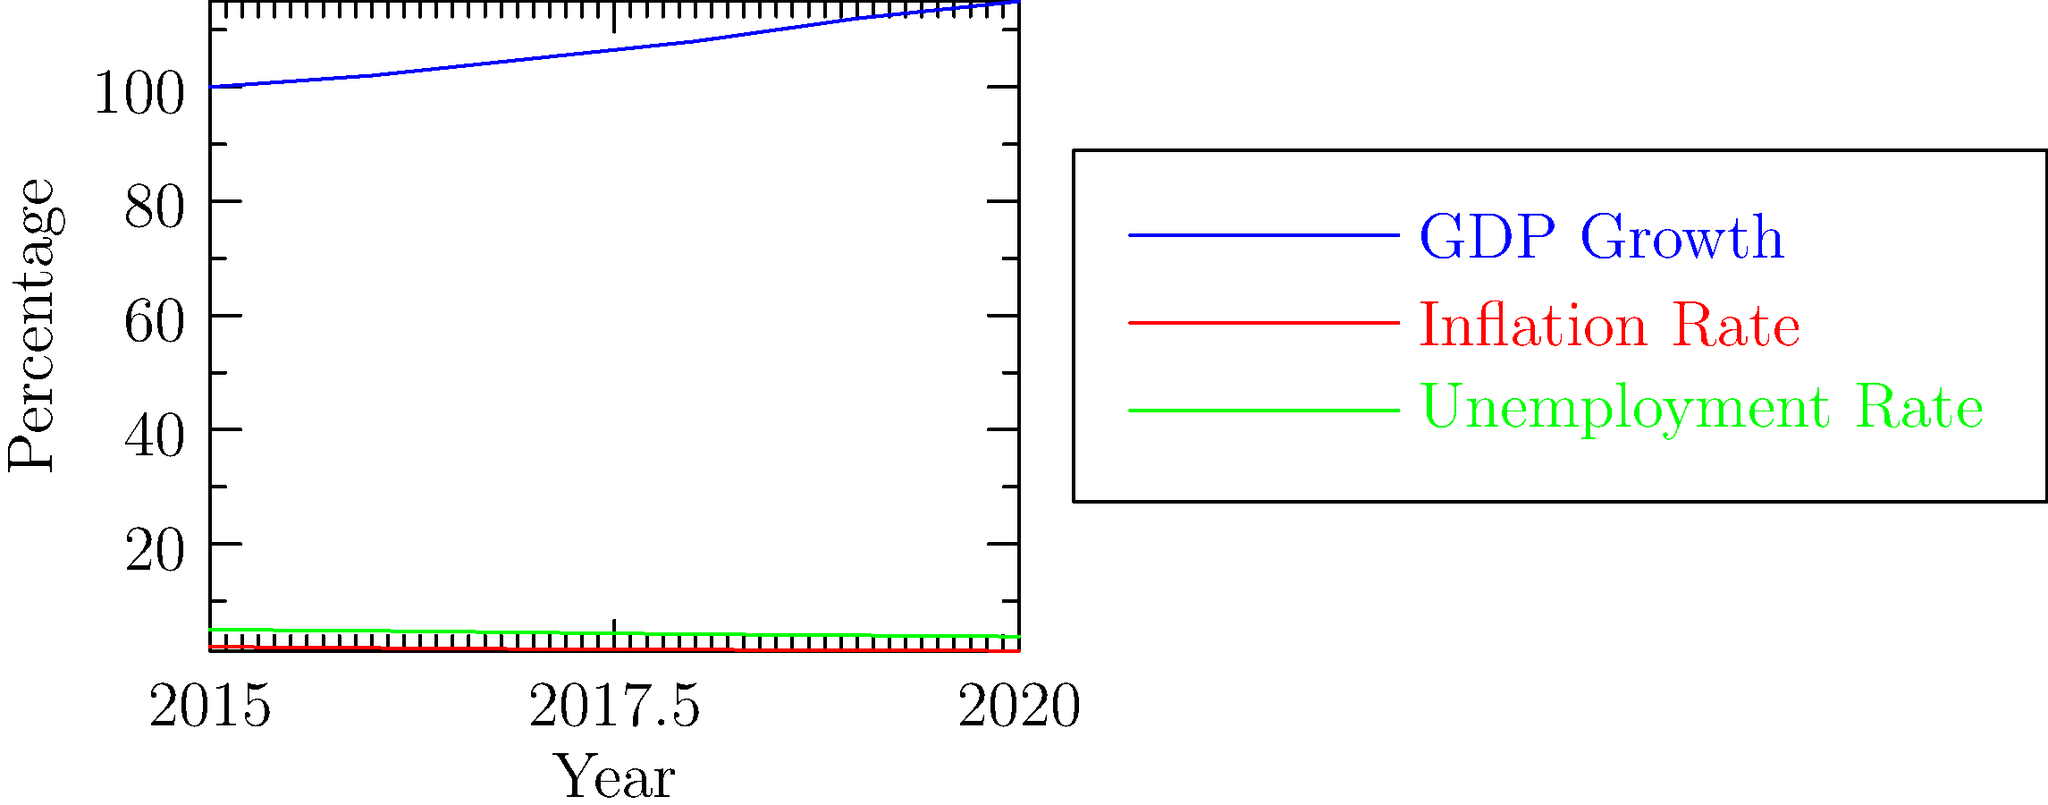Based on the economic indicators shown in the graph, which statement best supports the narrative of a thriving economy and stable political climate? To answer this question, we need to analyze the trends of the three economic indicators shown in the graph:

1. GDP Growth (blue line):
   - Shows a steady upward trend from 2015 to 2020
   - Increases from 100 to 115 over the period
   - Indicates consistent economic growth

2. Inflation Rate (red line):
   - Shows a gradual downward trend
   - Decreases from 2% to 1.3% over the period
   - Suggests price stability and controlled inflation

3. Unemployment Rate (green line):
   - Shows a consistent downward trend
   - Decreases from 5% to 3.8% over the period
   - Indicates improving job market conditions

The best statement to support a thriving economy and stable political climate would focus on the positive aspects of all three indicators:
- Consistent GDP growth
- Decreasing inflation rate (price stability)
- Declining unemployment rate (job market improvement)

These trends collectively suggest economic stability and growth, which can be used to imply a stable political climate.
Answer: Steady GDP growth, declining inflation, and decreasing unemployment demonstrate economic prosperity and stability. 